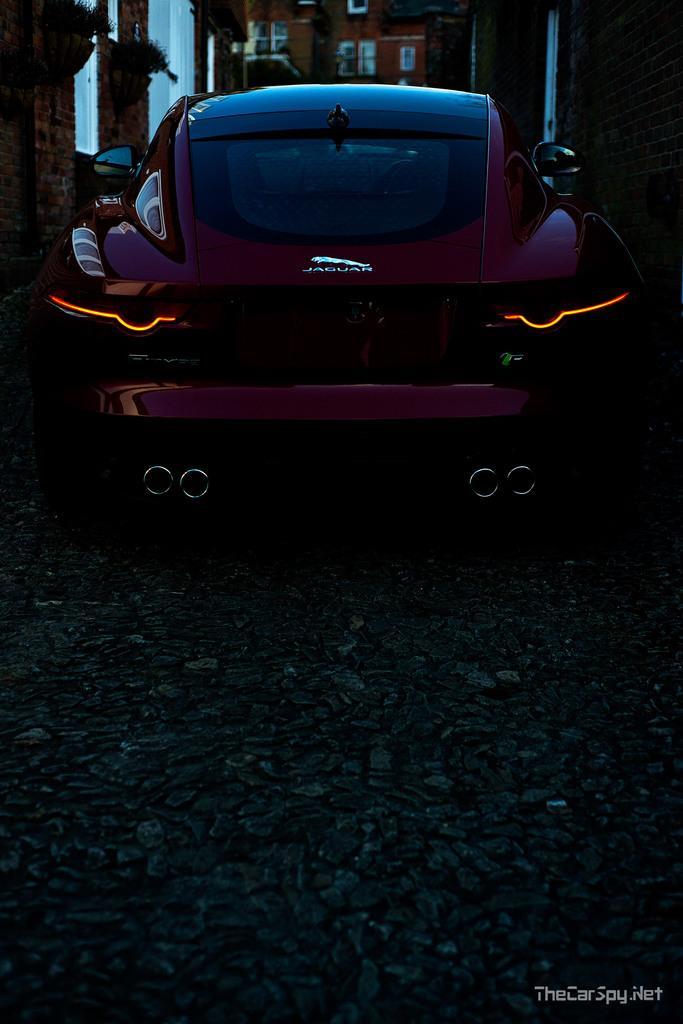Could you give a brief overview of what you see in this image? In this image i can see a vehicle and behind that i can see a building with windows. 